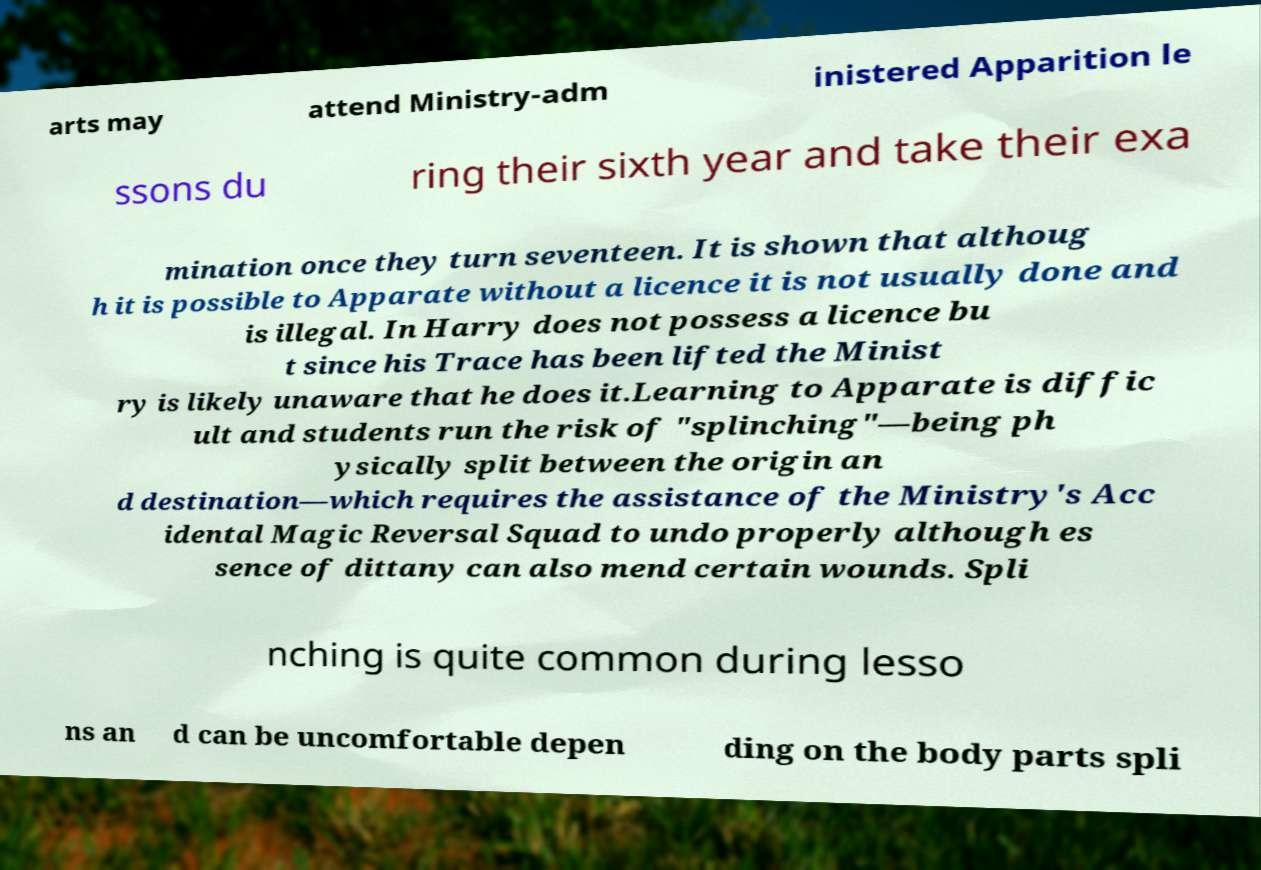I need the written content from this picture converted into text. Can you do that? arts may attend Ministry-adm inistered Apparition le ssons du ring their sixth year and take their exa mination once they turn seventeen. It is shown that althoug h it is possible to Apparate without a licence it is not usually done and is illegal. In Harry does not possess a licence bu t since his Trace has been lifted the Minist ry is likely unaware that he does it.Learning to Apparate is diffic ult and students run the risk of "splinching"—being ph ysically split between the origin an d destination—which requires the assistance of the Ministry's Acc idental Magic Reversal Squad to undo properly although es sence of dittany can also mend certain wounds. Spli nching is quite common during lesso ns an d can be uncomfortable depen ding on the body parts spli 